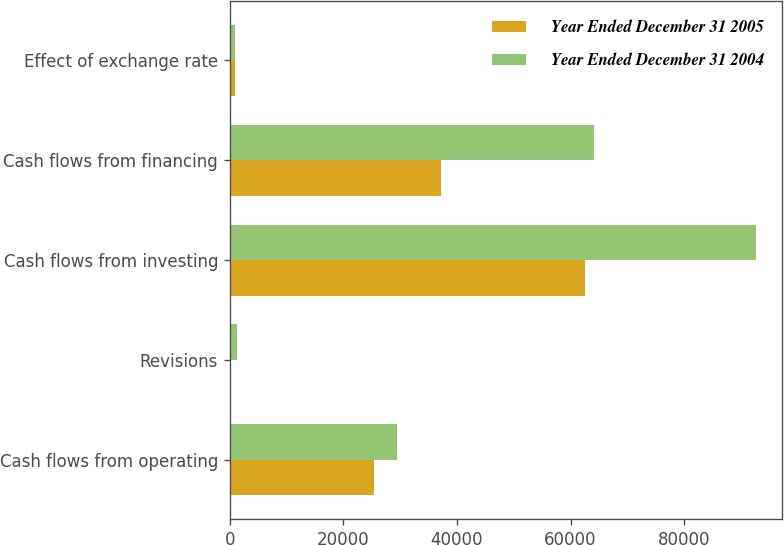Convert chart. <chart><loc_0><loc_0><loc_500><loc_500><stacked_bar_chart><ecel><fcel>Cash flows from operating<fcel>Revisions<fcel>Cash flows from investing<fcel>Cash flows from financing<fcel>Effect of exchange rate<nl><fcel>Year Ended December 31 2005<fcel>25382<fcel>244<fcel>62500<fcel>37169<fcel>928<nl><fcel>Year Ended December 31 2004<fcel>29414<fcel>1302<fcel>92596<fcel>64217<fcel>992<nl></chart> 